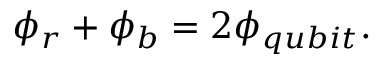Convert formula to latex. <formula><loc_0><loc_0><loc_500><loc_500>\phi _ { r } + \phi _ { b } = 2 \phi _ { q u b i t } .</formula> 